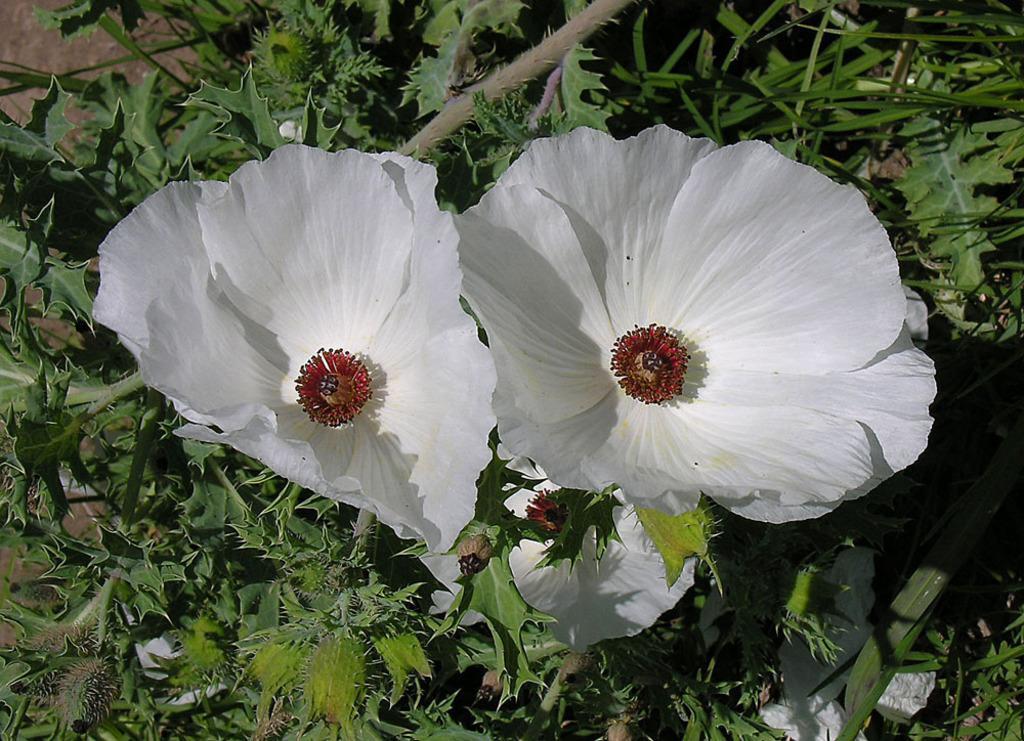Can you describe this image briefly? This image consists of flowers in white color. The pollen grains are in red color. At the bottom, there are plants along with trees. 